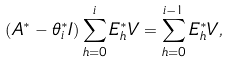<formula> <loc_0><loc_0><loc_500><loc_500>( A ^ { * } - \theta ^ { * } _ { i } I ) \sum _ { h = 0 } ^ { i } E ^ { * } _ { h } V = \sum _ { h = 0 } ^ { i - 1 } E ^ { * } _ { h } V ,</formula> 